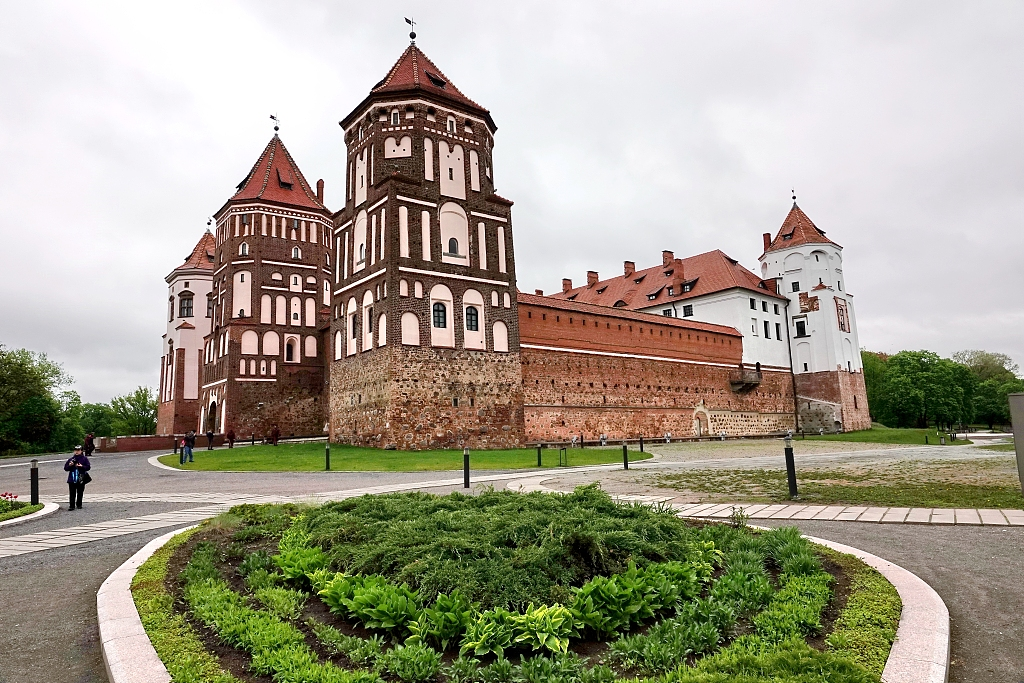Can you tell me more about the architectural style of the castle? The Mir Castle Complex exemplifies a unique blend of Gothic, Baroque, and Renaissance architectural styles. This fusion is evident in its robust red brick structures and intricate decorative elements. The Gothic influence is apparent in the robust, fortress-like towers and the pointed roofs, while the Renaissance elements can be seen in the elegant arcades and the ornamental stonework. The Baroque style is reflected in the castle's detailed façades and the decorative, almost theatrical, design flourishes. The combination of these styles gives the castle its distinctive and compelling appearance. 